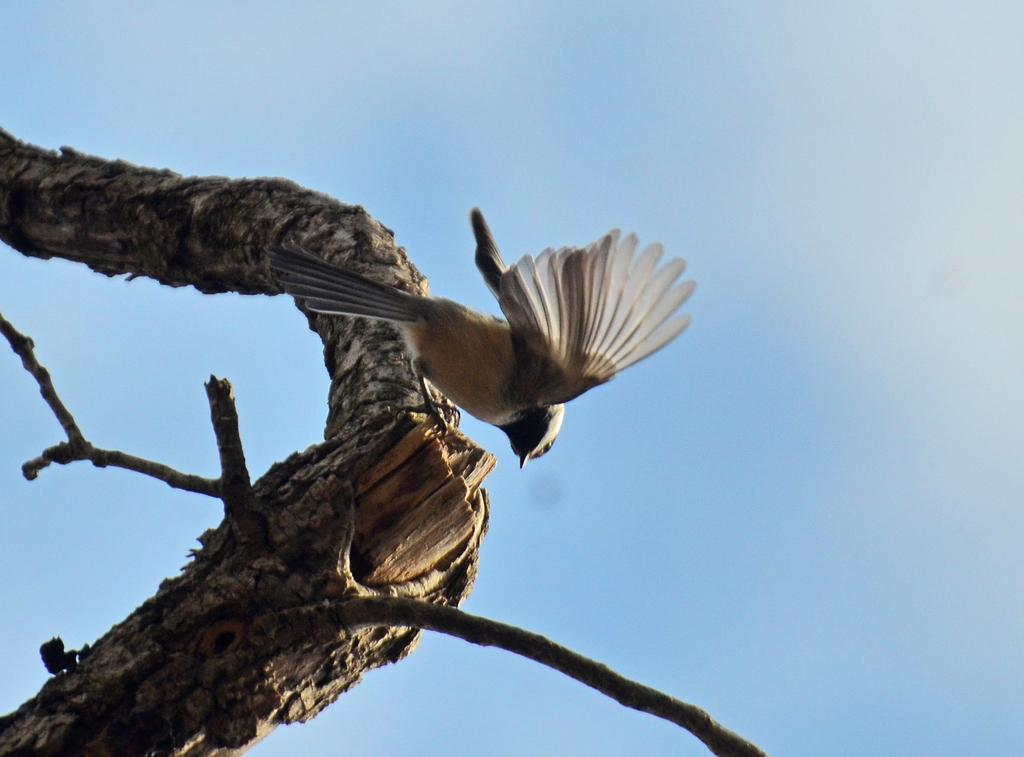What is located on the left side of the image? There is a tree trunk on the left side of the image. What is happening in the image involving a bird? A bird is flying in the image. What is visible at the top of the image? The sky is visible at the top of the image. What type of wine is being poured from the tree trunk in the image? There is no wine present in the image; it features a tree trunk and a flying bird. What is the texture of the liquid being poured from the tree trunk in the image? There is no liquid being poured from the tree trunk in the image. 